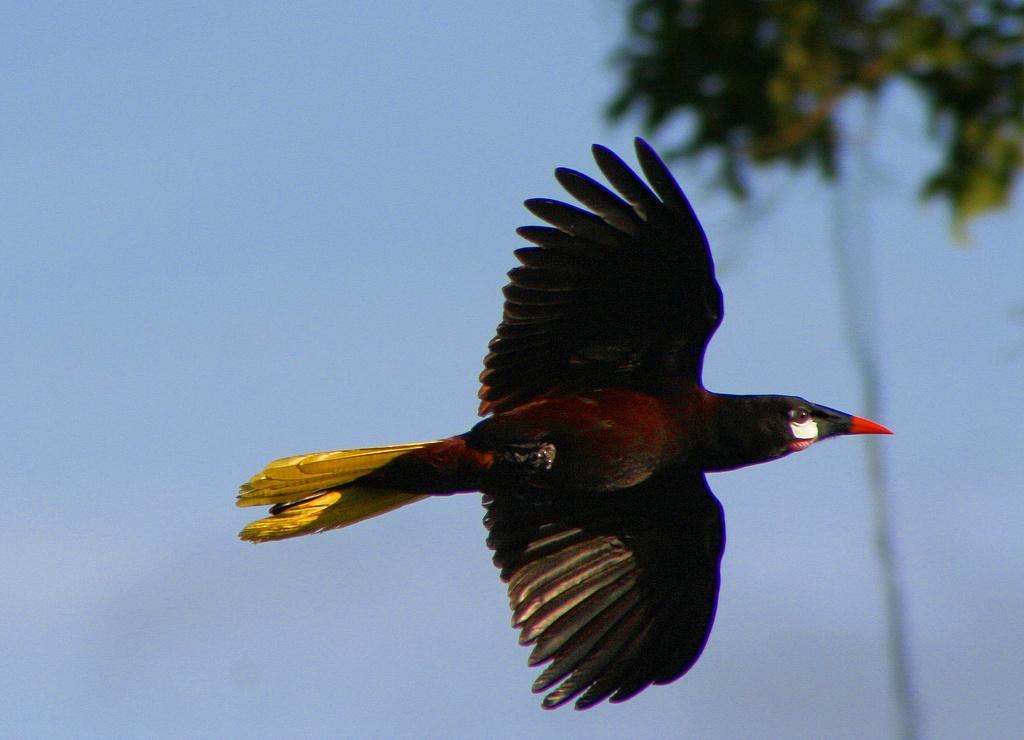What is the main subject of the image? There is a bird flying in the image. What can be seen in the background of the image? There is a tree and a wire in the background of the image. What is visible above the tree and wire? The sky is visible in the background of the image. What color is the crayon being used by the bird in the image? There is no crayon present in the image, and the bird is not using any crayon. What type of patch is visible on the bird's wing in the image? There is no patch visible on the bird's wing in the image. 